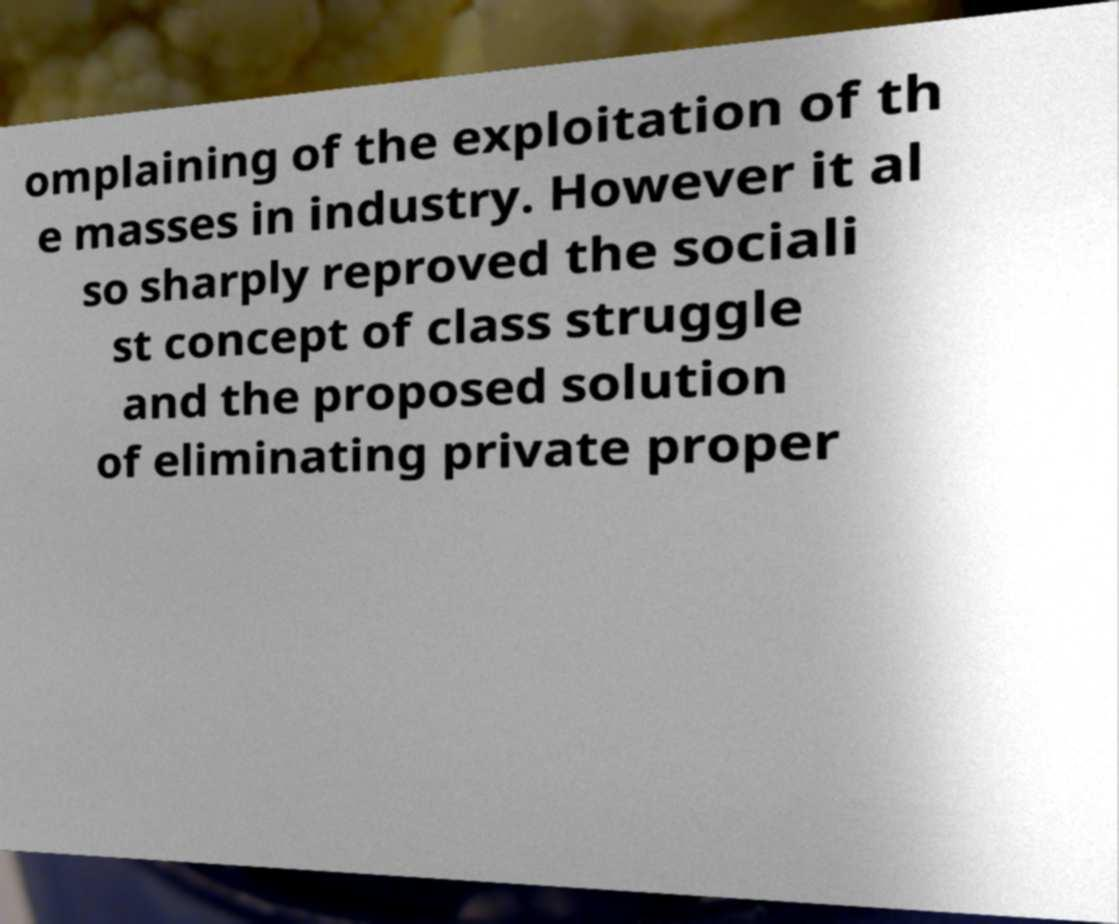Please identify and transcribe the text found in this image. omplaining of the exploitation of th e masses in industry. However it al so sharply reproved the sociali st concept of class struggle and the proposed solution of eliminating private proper 